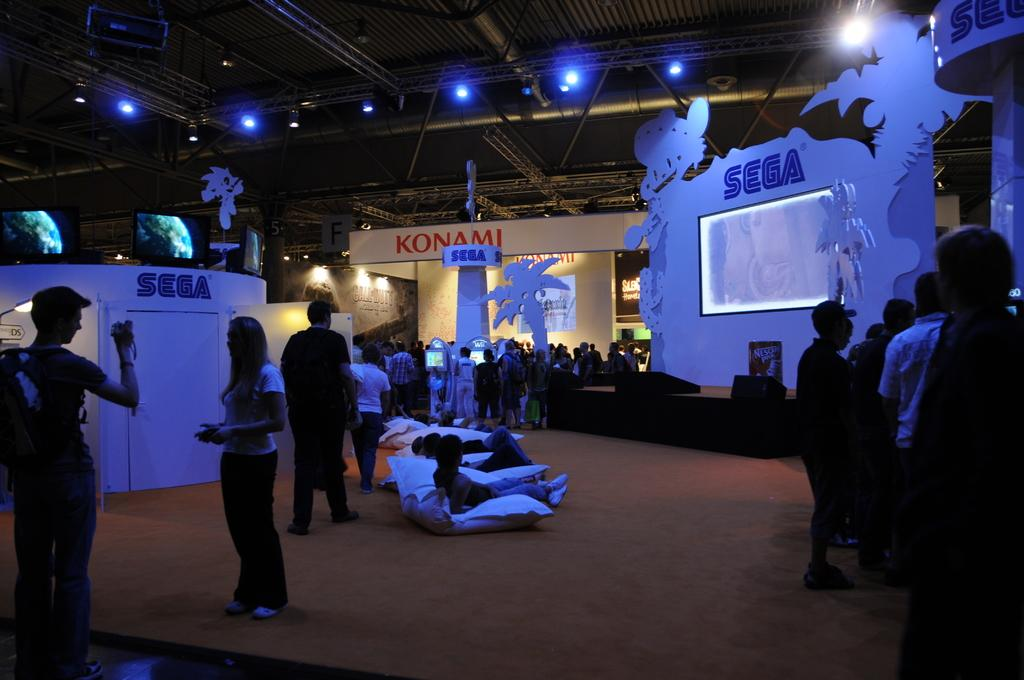How many people are present in the hall in the image? There are many people standing in the hall in the image. What type of lighting is present in the hall? There are ceiling lights visible in the image. What can be seen on the right side of the image? There is a screen on the right side of the image. What is located on the left side of the image? There is a room on the left side of the image. What type of care is being provided to the group in the image? There is no indication in the image that any type of care is being provided to a group. 